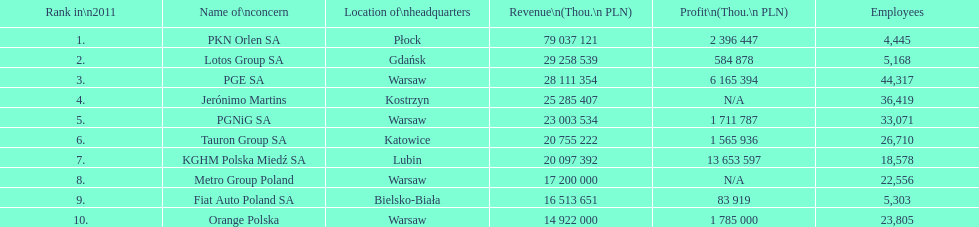What company is the only one with a revenue greater than 75,000,000 thou. pln? PKN Orlen SA. 